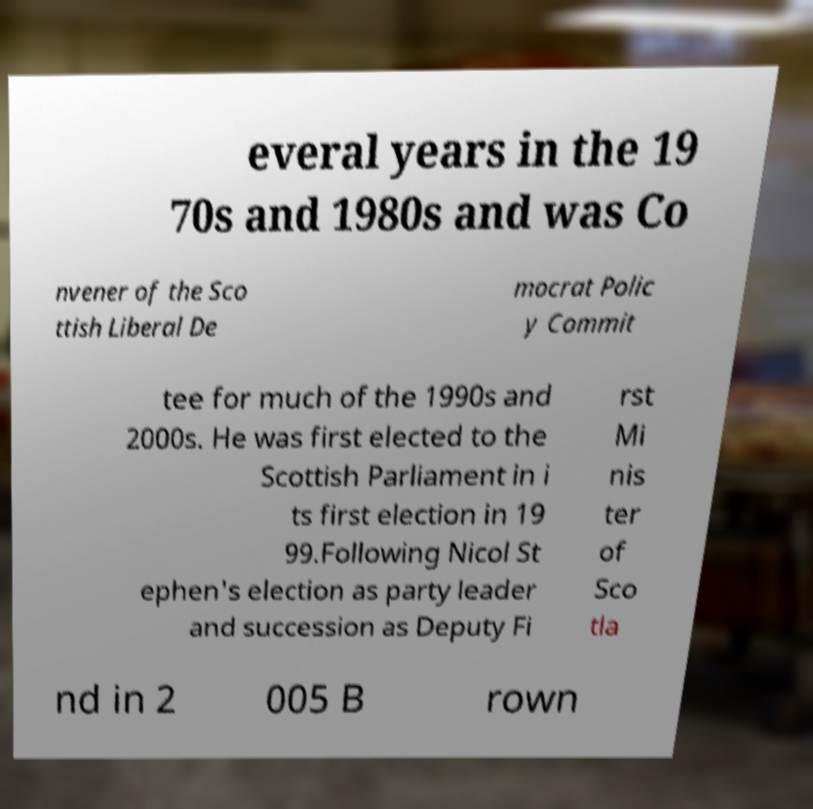For documentation purposes, I need the text within this image transcribed. Could you provide that? everal years in the 19 70s and 1980s and was Co nvener of the Sco ttish Liberal De mocrat Polic y Commit tee for much of the 1990s and 2000s. He was first elected to the Scottish Parliament in i ts first election in 19 99.Following Nicol St ephen's election as party leader and succession as Deputy Fi rst Mi nis ter of Sco tla nd in 2 005 B rown 